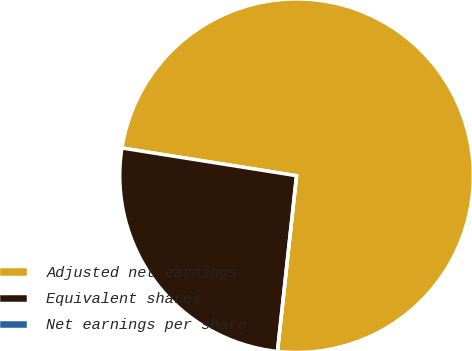Convert chart to OTSL. <chart><loc_0><loc_0><loc_500><loc_500><pie_chart><fcel>Adjusted net earnings<fcel>Equivalent shares<fcel>Net earnings per share<nl><fcel>74.22%<fcel>25.78%<fcel>0.0%<nl></chart> 